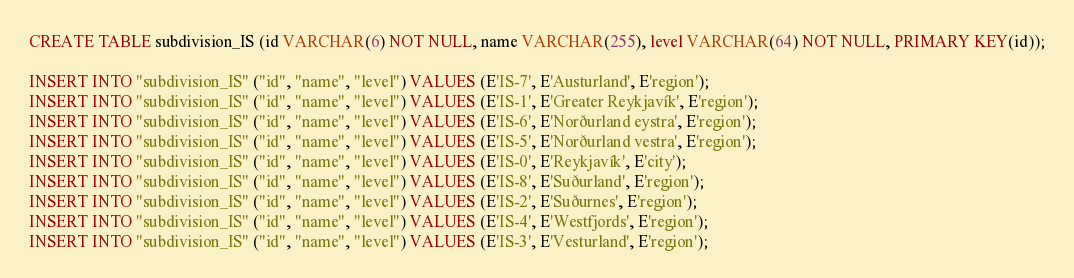Convert code to text. <code><loc_0><loc_0><loc_500><loc_500><_SQL_>CREATE TABLE subdivision_IS (id VARCHAR(6) NOT NULL, name VARCHAR(255), level VARCHAR(64) NOT NULL, PRIMARY KEY(id));

INSERT INTO "subdivision_IS" ("id", "name", "level") VALUES (E'IS-7', E'Austurland', E'region');
INSERT INTO "subdivision_IS" ("id", "name", "level") VALUES (E'IS-1', E'Greater Reykjavík', E'region');
INSERT INTO "subdivision_IS" ("id", "name", "level") VALUES (E'IS-6', E'Norðurland eystra', E'region');
INSERT INTO "subdivision_IS" ("id", "name", "level") VALUES (E'IS-5', E'Norðurland vestra', E'region');
INSERT INTO "subdivision_IS" ("id", "name", "level") VALUES (E'IS-0', E'Reykjavík', E'city');
INSERT INTO "subdivision_IS" ("id", "name", "level") VALUES (E'IS-8', E'Suðurland', E'region');
INSERT INTO "subdivision_IS" ("id", "name", "level") VALUES (E'IS-2', E'Suðurnes', E'region');
INSERT INTO "subdivision_IS" ("id", "name", "level") VALUES (E'IS-4', E'Westfjords', E'region');
INSERT INTO "subdivision_IS" ("id", "name", "level") VALUES (E'IS-3', E'Vesturland', E'region');
</code> 